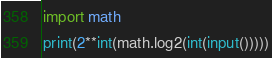Convert code to text. <code><loc_0><loc_0><loc_500><loc_500><_Python_>import math
print(2**int(math.log2(int(input()))))</code> 